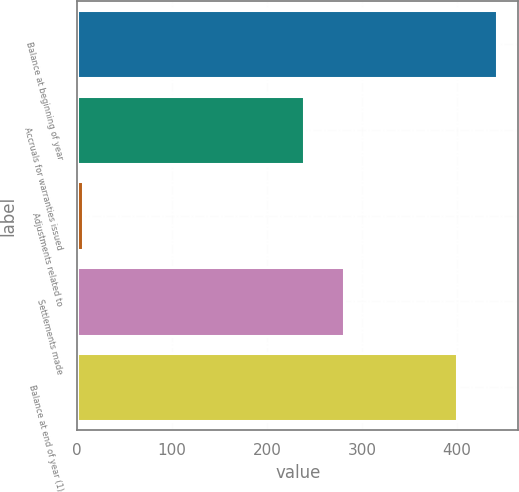Convert chart to OTSL. <chart><loc_0><loc_0><loc_500><loc_500><bar_chart><fcel>Balance at beginning of year<fcel>Accruals for warranties issued<fcel>Adjustments related to<fcel>Settlements made<fcel>Balance at end of year (1)<nl><fcel>442.4<fcel>239<fcel>6<fcel>281.4<fcel>400<nl></chart> 